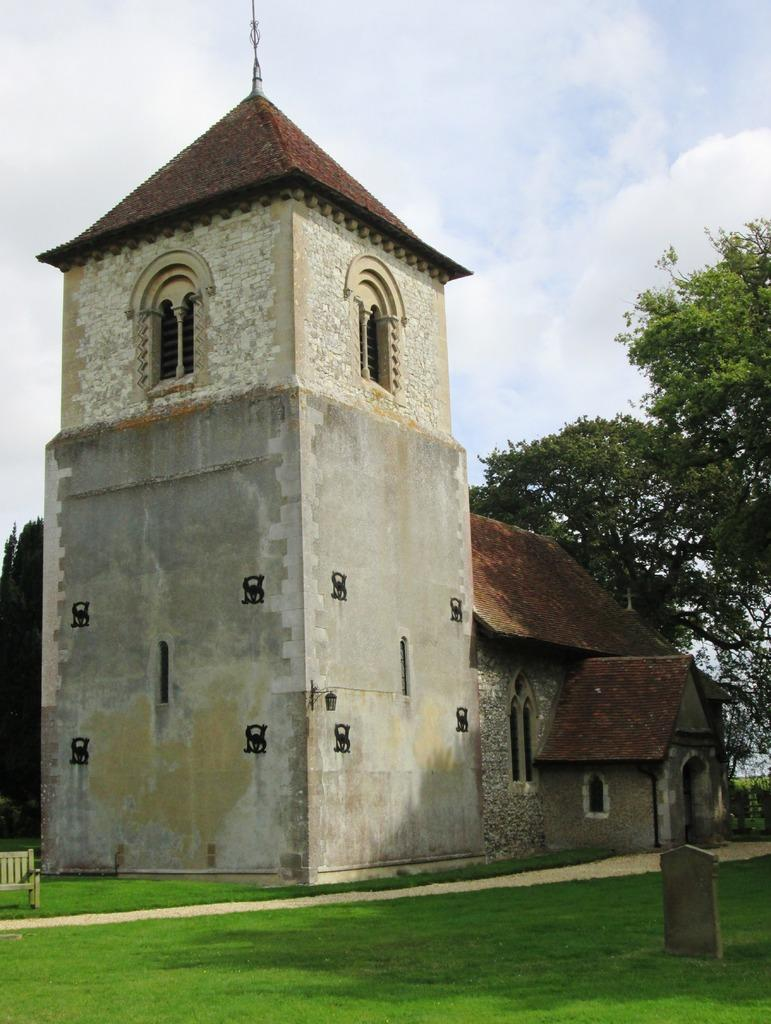What type of structure is present in the image? There is a building in the image. What colors are used for the building? The building is in white and gray colors. What can be seen in the background of the image? There are trees in the background of the image. What color are the trees? The trees are in green color. What else is visible in the image? The sky is visible in the image. What colors are used for the sky? The sky is in white and blue colors. Where is the baby bear with the chicken playing in the image? There is no baby bear or chicken present in the image; it only features a building, trees, and the sky. 